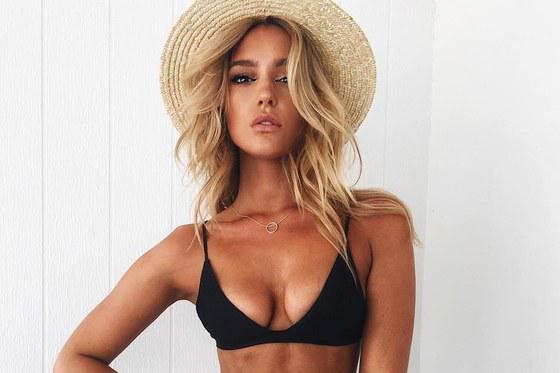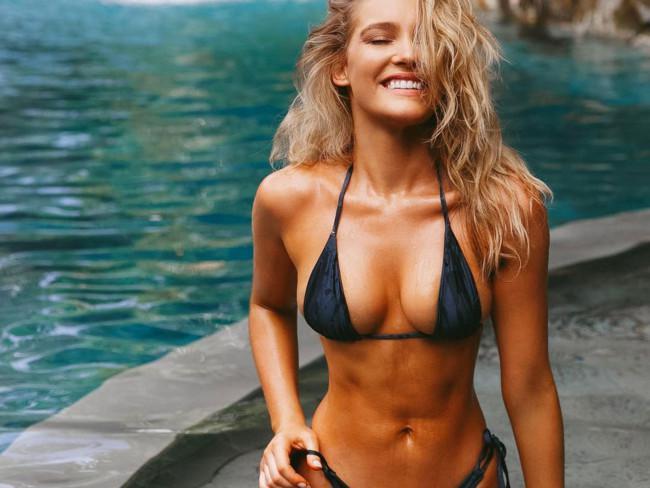The first image is the image on the left, the second image is the image on the right. For the images shown, is this caption "A woman is sitting." true? Answer yes or no. No. 